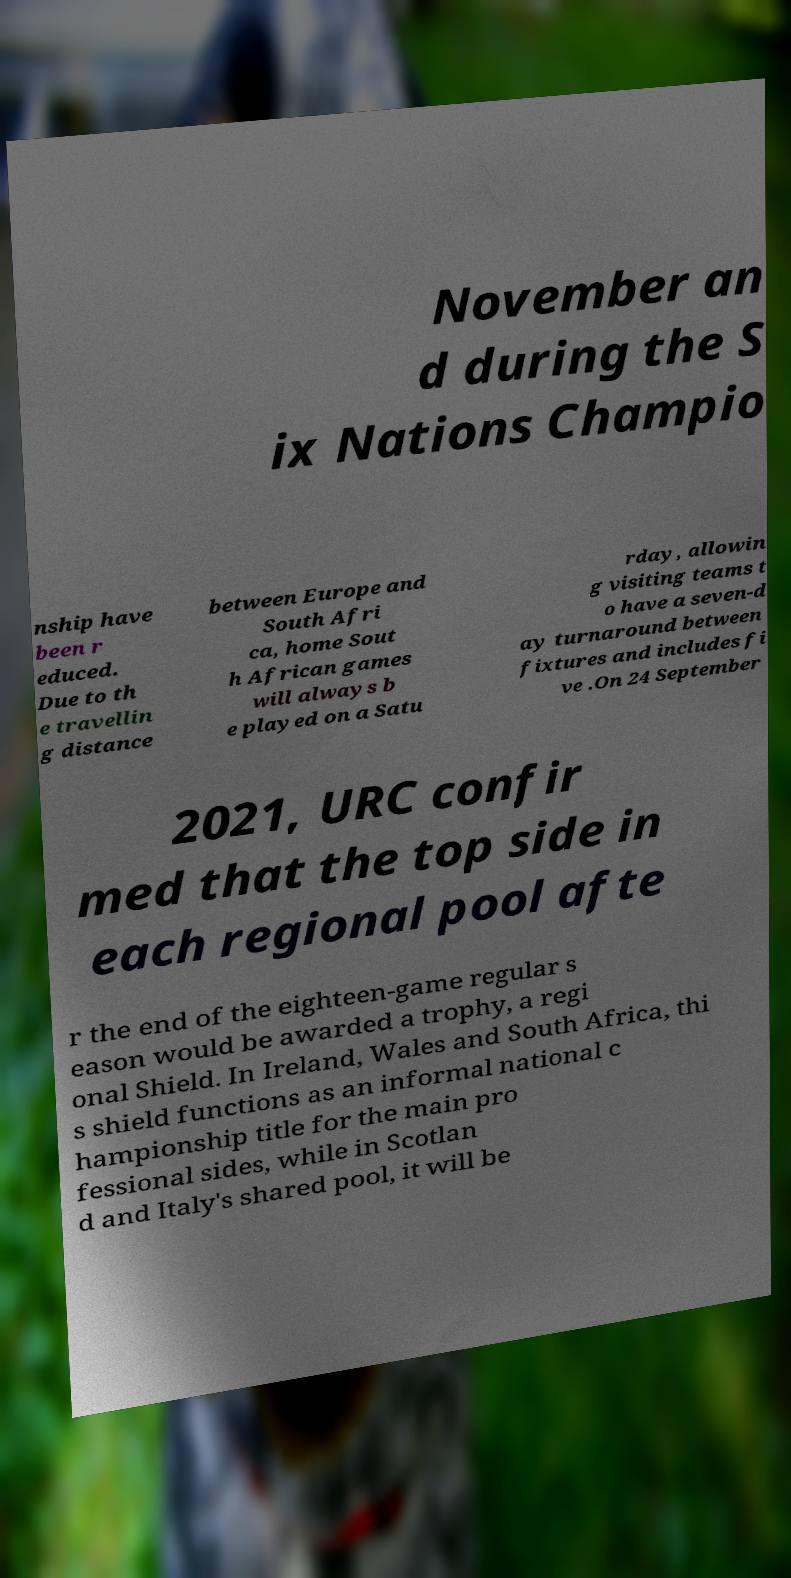Can you read and provide the text displayed in the image?This photo seems to have some interesting text. Can you extract and type it out for me? November an d during the S ix Nations Champio nship have been r educed. Due to th e travellin g distance between Europe and South Afri ca, home Sout h African games will always b e played on a Satu rday, allowin g visiting teams t o have a seven-d ay turnaround between fixtures and includes fi ve .On 24 September 2021, URC confir med that the top side in each regional pool afte r the end of the eighteen-game regular s eason would be awarded a trophy, a regi onal Shield. In Ireland, Wales and South Africa, thi s shield functions as an informal national c hampionship title for the main pro fessional sides, while in Scotlan d and Italy's shared pool, it will be 